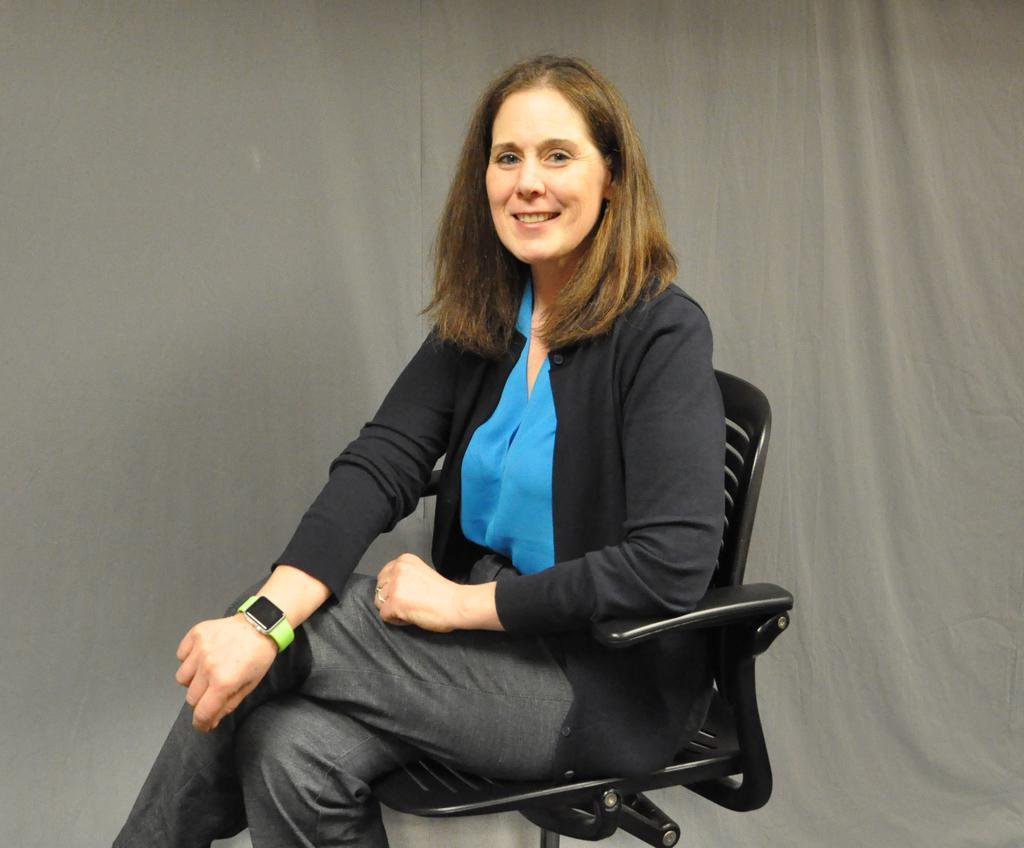Could you give a brief overview of what you see in this image? In this image there is a women with blue shirt, black jacket sitting on a black chair. She is smiling and there is a watch to her right hand. At the back there is a grey curtain. 